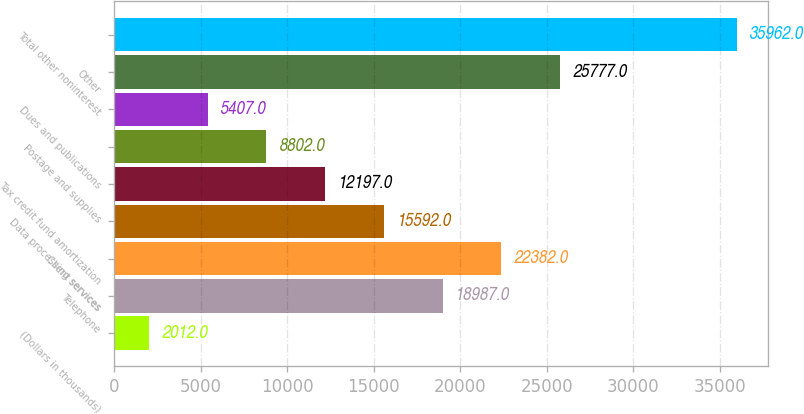Convert chart to OTSL. <chart><loc_0><loc_0><loc_500><loc_500><bar_chart><fcel>(Dollars in thousands)<fcel>Telephone<fcel>Client services<fcel>Data processing services<fcel>Tax credit fund amortization<fcel>Postage and supplies<fcel>Dues and publications<fcel>Other<fcel>Total other noninterest<nl><fcel>2012<fcel>18987<fcel>22382<fcel>15592<fcel>12197<fcel>8802<fcel>5407<fcel>25777<fcel>35962<nl></chart> 